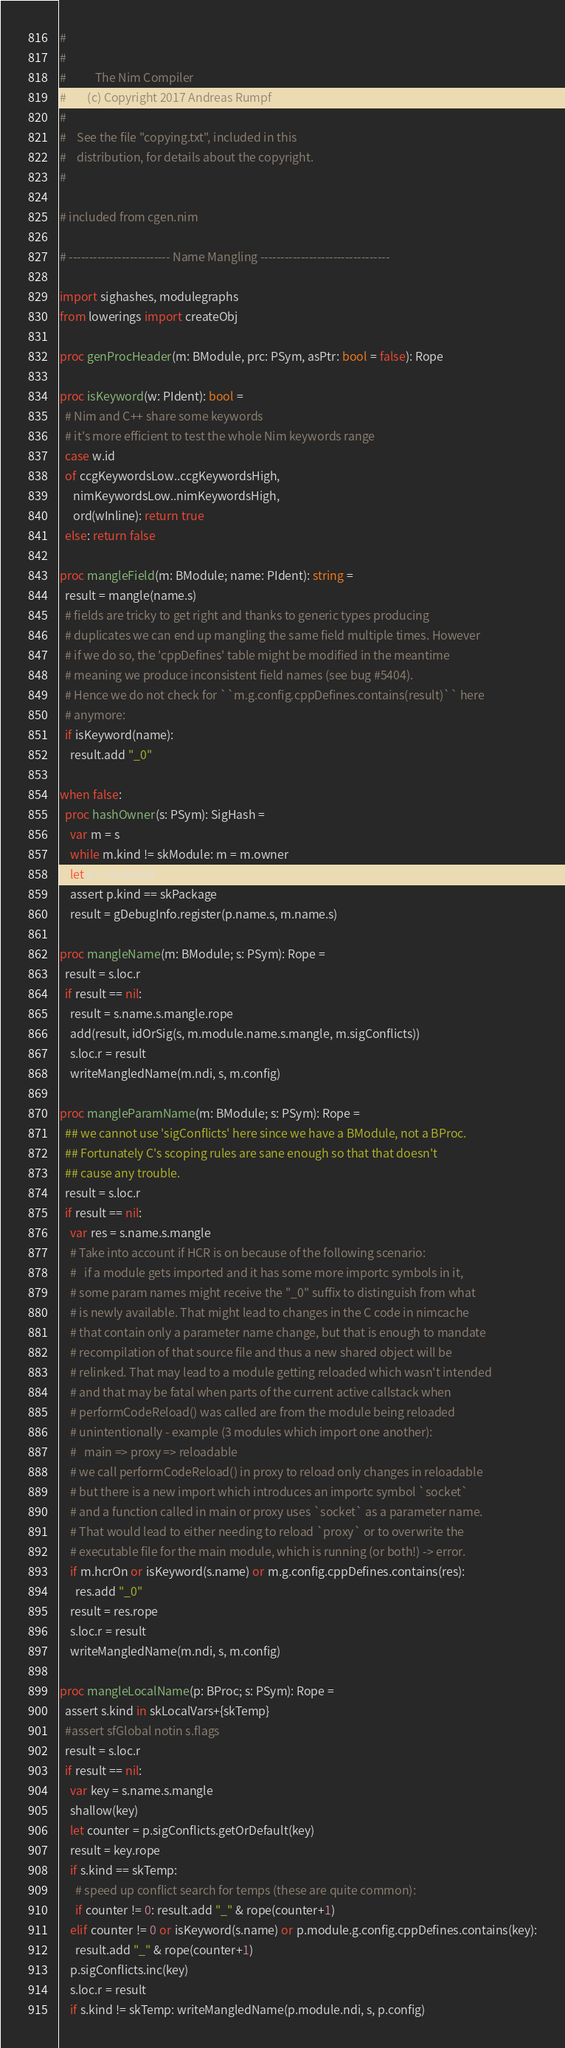Convert code to text. <code><loc_0><loc_0><loc_500><loc_500><_Nim_>#
#
#           The Nim Compiler
#        (c) Copyright 2017 Andreas Rumpf
#
#    See the file "copying.txt", included in this
#    distribution, for details about the copyright.
#

# included from cgen.nim

# ------------------------- Name Mangling --------------------------------

import sighashes, modulegraphs
from lowerings import createObj

proc genProcHeader(m: BModule, prc: PSym, asPtr: bool = false): Rope

proc isKeyword(w: PIdent): bool =
  # Nim and C++ share some keywords
  # it's more efficient to test the whole Nim keywords range
  case w.id
  of ccgKeywordsLow..ccgKeywordsHigh,
     nimKeywordsLow..nimKeywordsHigh,
     ord(wInline): return true
  else: return false

proc mangleField(m: BModule; name: PIdent): string =
  result = mangle(name.s)
  # fields are tricky to get right and thanks to generic types producing
  # duplicates we can end up mangling the same field multiple times. However
  # if we do so, the 'cppDefines' table might be modified in the meantime
  # meaning we produce inconsistent field names (see bug #5404).
  # Hence we do not check for ``m.g.config.cppDefines.contains(result)`` here
  # anymore:
  if isKeyword(name):
    result.add "_0"

when false:
  proc hashOwner(s: PSym): SigHash =
    var m = s
    while m.kind != skModule: m = m.owner
    let p = m.owner
    assert p.kind == skPackage
    result = gDebugInfo.register(p.name.s, m.name.s)

proc mangleName(m: BModule; s: PSym): Rope =
  result = s.loc.r
  if result == nil:
    result = s.name.s.mangle.rope
    add(result, idOrSig(s, m.module.name.s.mangle, m.sigConflicts))
    s.loc.r = result
    writeMangledName(m.ndi, s, m.config)

proc mangleParamName(m: BModule; s: PSym): Rope =
  ## we cannot use 'sigConflicts' here since we have a BModule, not a BProc.
  ## Fortunately C's scoping rules are sane enough so that that doesn't
  ## cause any trouble.
  result = s.loc.r
  if result == nil:
    var res = s.name.s.mangle
    # Take into account if HCR is on because of the following scenario:
    #   if a module gets imported and it has some more importc symbols in it,
    # some param names might receive the "_0" suffix to distinguish from what
    # is newly available. That might lead to changes in the C code in nimcache
    # that contain only a parameter name change, but that is enough to mandate
    # recompilation of that source file and thus a new shared object will be
    # relinked. That may lead to a module getting reloaded which wasn't intended
    # and that may be fatal when parts of the current active callstack when
    # performCodeReload() was called are from the module being reloaded
    # unintentionally - example (3 modules which import one another):
    #   main => proxy => reloadable
    # we call performCodeReload() in proxy to reload only changes in reloadable
    # but there is a new import which introduces an importc symbol `socket`
    # and a function called in main or proxy uses `socket` as a parameter name.
    # That would lead to either needing to reload `proxy` or to overwrite the
    # executable file for the main module, which is running (or both!) -> error.
    if m.hcrOn or isKeyword(s.name) or m.g.config.cppDefines.contains(res):
      res.add "_0"
    result = res.rope
    s.loc.r = result
    writeMangledName(m.ndi, s, m.config)

proc mangleLocalName(p: BProc; s: PSym): Rope =
  assert s.kind in skLocalVars+{skTemp}
  #assert sfGlobal notin s.flags
  result = s.loc.r
  if result == nil:
    var key = s.name.s.mangle
    shallow(key)
    let counter = p.sigConflicts.getOrDefault(key)
    result = key.rope
    if s.kind == skTemp:
      # speed up conflict search for temps (these are quite common):
      if counter != 0: result.add "_" & rope(counter+1)
    elif counter != 0 or isKeyword(s.name) or p.module.g.config.cppDefines.contains(key):
      result.add "_" & rope(counter+1)
    p.sigConflicts.inc(key)
    s.loc.r = result
    if s.kind != skTemp: writeMangledName(p.module.ndi, s, p.config)
</code> 